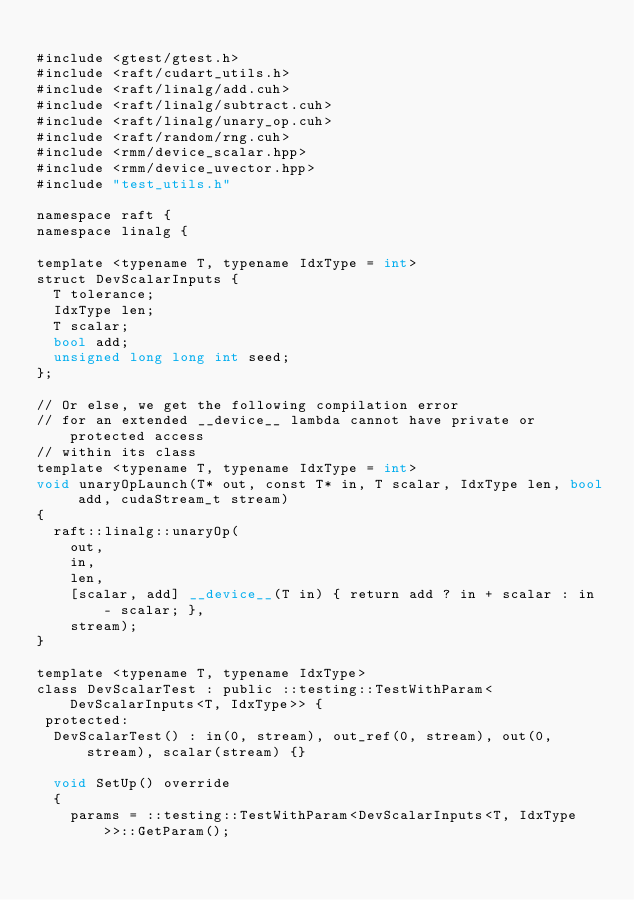Convert code to text. <code><loc_0><loc_0><loc_500><loc_500><_Cuda_>
#include <gtest/gtest.h>
#include <raft/cudart_utils.h>
#include <raft/linalg/add.cuh>
#include <raft/linalg/subtract.cuh>
#include <raft/linalg/unary_op.cuh>
#include <raft/random/rng.cuh>
#include <rmm/device_scalar.hpp>
#include <rmm/device_uvector.hpp>
#include "test_utils.h"

namespace raft {
namespace linalg {

template <typename T, typename IdxType = int>
struct DevScalarInputs {
  T tolerance;
  IdxType len;
  T scalar;
  bool add;
  unsigned long long int seed;
};

// Or else, we get the following compilation error
// for an extended __device__ lambda cannot have private or protected access
// within its class
template <typename T, typename IdxType = int>
void unaryOpLaunch(T* out, const T* in, T scalar, IdxType len, bool add, cudaStream_t stream)
{
  raft::linalg::unaryOp(
    out,
    in,
    len,
    [scalar, add] __device__(T in) { return add ? in + scalar : in - scalar; },
    stream);
}

template <typename T, typename IdxType>
class DevScalarTest : public ::testing::TestWithParam<DevScalarInputs<T, IdxType>> {
 protected:
  DevScalarTest() : in(0, stream), out_ref(0, stream), out(0, stream), scalar(stream) {}

  void SetUp() override
  {
    params = ::testing::TestWithParam<DevScalarInputs<T, IdxType>>::GetParam();</code> 